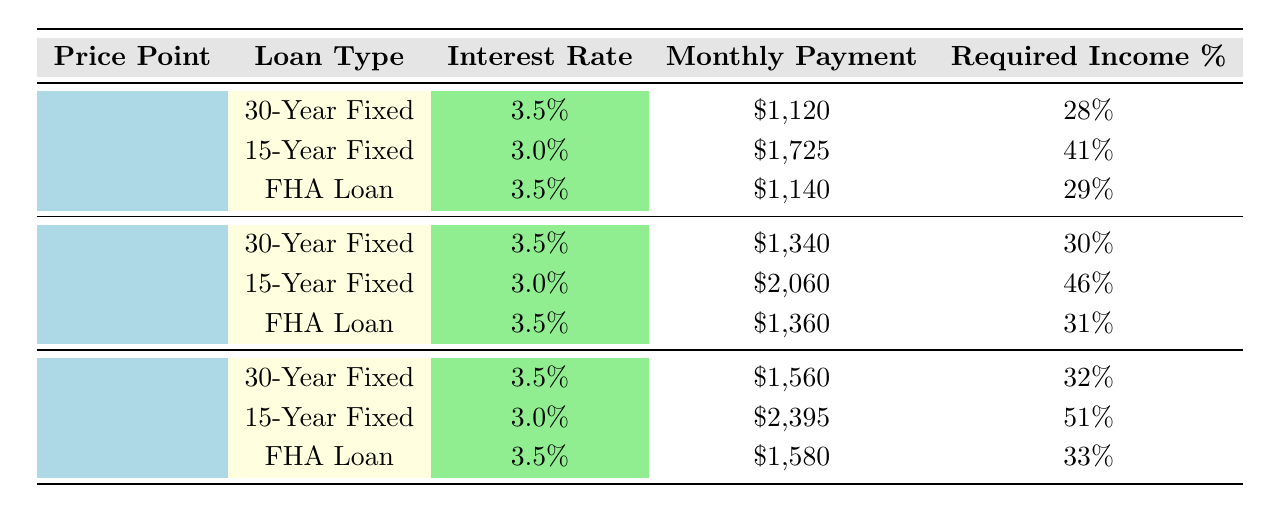What is the required income percentage for a 30-Year Fixed Mortgage at a price point of $300,000? The table shows that for the price point of $300,000 using a 30-Year Fixed Mortgage, the required income percentage is 30%.
Answer: 30% What is the monthly payment for a $350,000 home using a FHA loan? The monthly payment for a $350,000 home with a FHA loan is $1,580, as indicated in the table.
Answer: $1,580 How much higher is the required income percentage for a 15-Year Fixed Mortgage at $350,000 compared to a 30-Year Fixed Mortgage at $250,000? The required income percentage for a 15-Year Fixed Mortgage at $350,000 is 51%, while for a 30-Year Fixed Mortgage at $250,000 it is 28%. The difference is 51% - 28% = 23%.
Answer: 23% Is the required income percentage for a FHA loan at $250,000 greater than that for a 30-Year Fixed Mortgage at the same price point? The required income percentage for a FHA loan at $250,000 is 29%, and for a 30-Year Fixed Mortgage at the same price point it is 28%. Since 29% is greater than 28%, the statement is true.
Answer: Yes What is the average monthly payment of a 30-Year Fixed Mortgage across the three price points? The monthly payments for a 30-Year Fixed Mortgage are $1,120 (for $250,000), $1,340 (for $300,000), and $1,560 (for $350,000). The average is calculated as follows: (1,120 + 1,340 + 1,560) / 3 = 1,340.
Answer: $1,340 What is the highest required income percentage for a 15-Year Fixed Mortgage at any price point? The required income percentages for a 15-Year Fixed Mortgage are 41% (for $250,000), 46% (for $300,000), and 51% (for $350,000). The highest percentage is 51% for the $350,000 price point.
Answer: 51% Is it true that the monthly payment for a FHA loan increases with the price point? By examining the table, the monthly payments for the FHA loan at $250,000, $300,000, and $350,000 are $1,140, $1,360, and $1,580, respectively. Since all values increase as the price point increases, the statement is true.
Answer: Yes What is the difference in monthly payment between a 15-Year Fixed Mortgage and a 30-Year Fixed Mortgage for a $300,000 home? For a $300,000 home, the monthly payment for the 15-Year Fixed Mortgage is $2,060, while for the 30-Year Fixed Mortgage it is $1,340. The difference is $2,060 - $1,340 = $720.
Answer: $720 